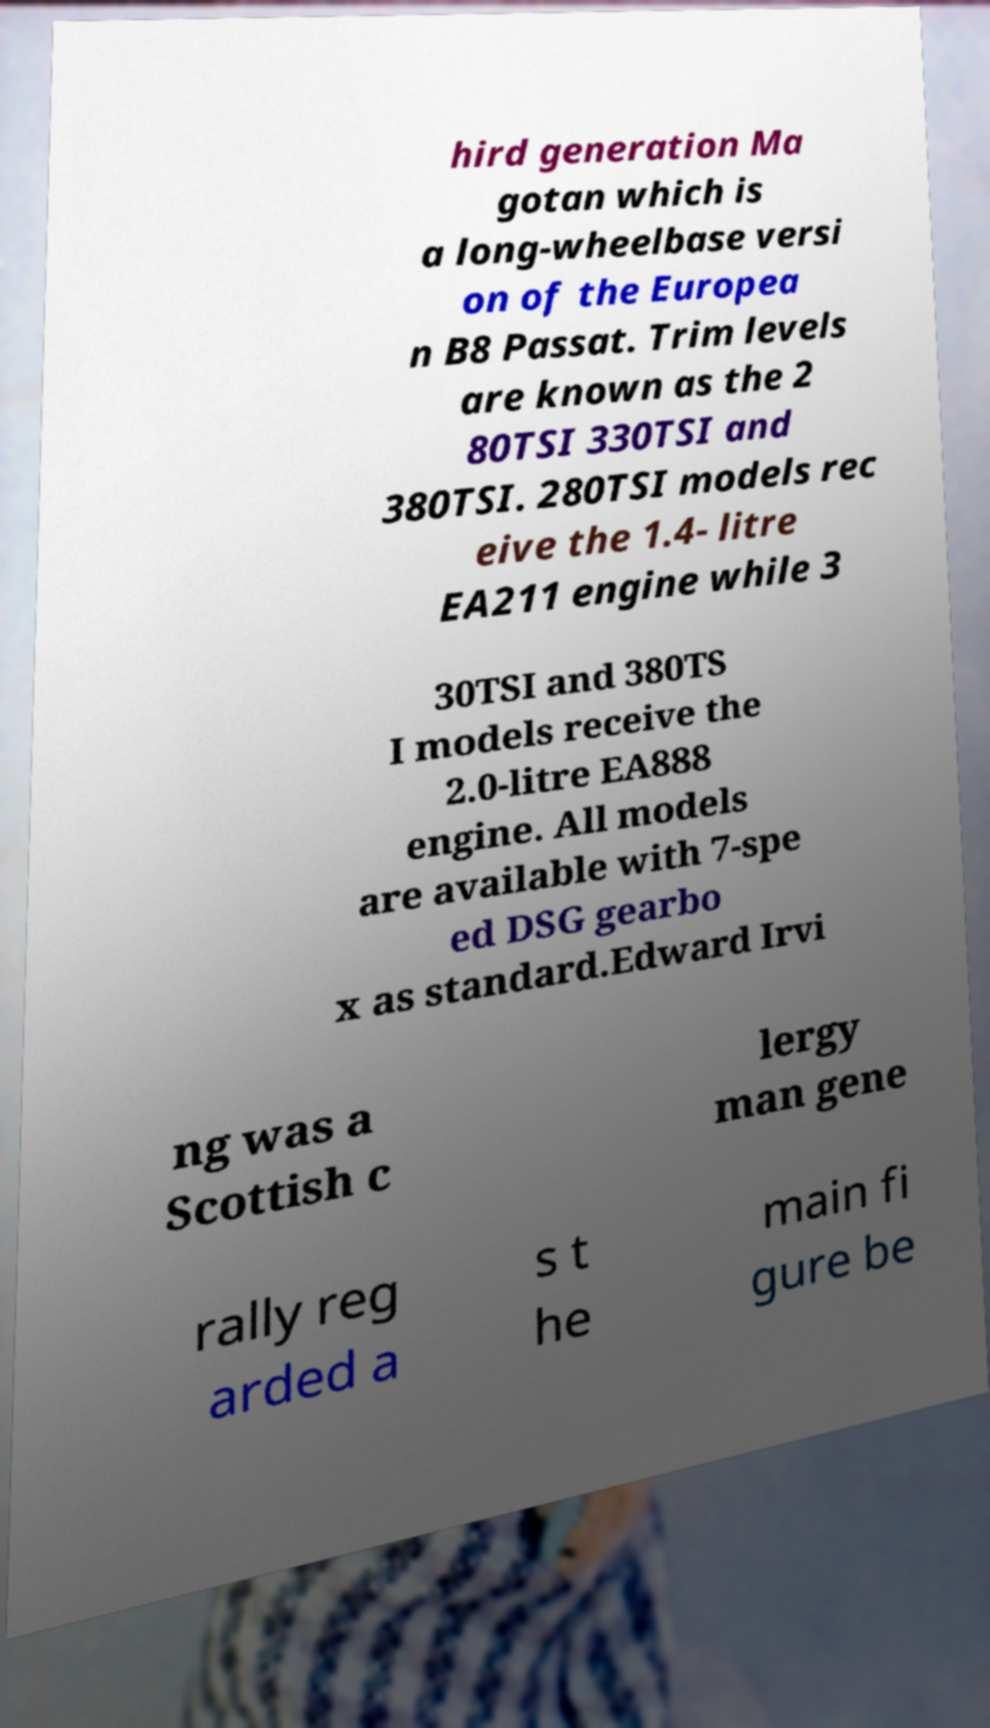For documentation purposes, I need the text within this image transcribed. Could you provide that? hird generation Ma gotan which is a long-wheelbase versi on of the Europea n B8 Passat. Trim levels are known as the 2 80TSI 330TSI and 380TSI. 280TSI models rec eive the 1.4- litre EA211 engine while 3 30TSI and 380TS I models receive the 2.0-litre EA888 engine. All models are available with 7-spe ed DSG gearbo x as standard.Edward Irvi ng was a Scottish c lergy man gene rally reg arded a s t he main fi gure be 